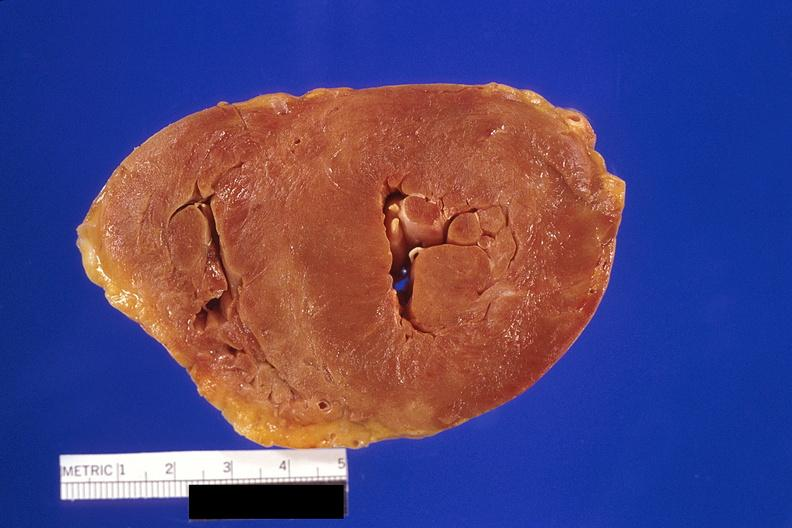where is this?
Answer the question using a single word or phrase. Heart 